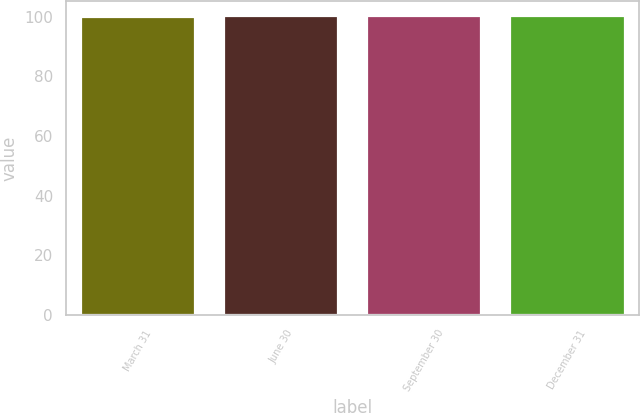Convert chart. <chart><loc_0><loc_0><loc_500><loc_500><bar_chart><fcel>March 31<fcel>June 30<fcel>September 30<fcel>December 31<nl><fcel>100<fcel>100.1<fcel>100.2<fcel>100.3<nl></chart> 